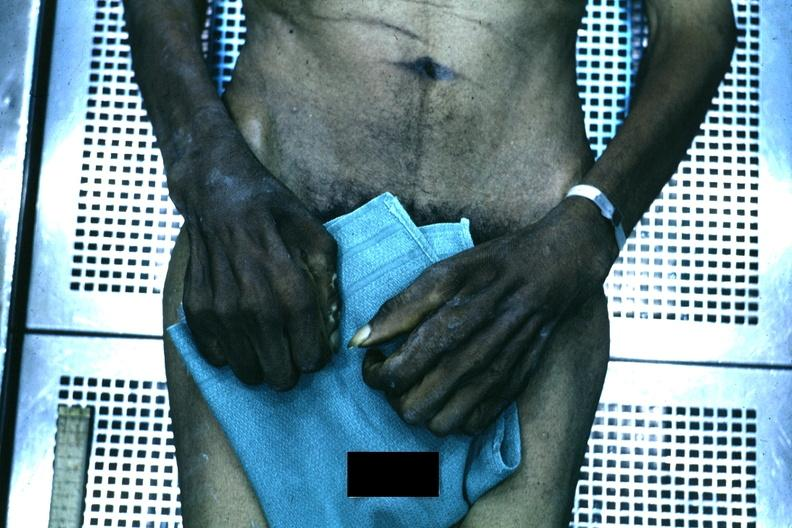re extremities present?
Answer the question using a single word or phrase. Yes 